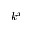<formula> <loc_0><loc_0><loc_500><loc_500>k ^ { x }</formula> 